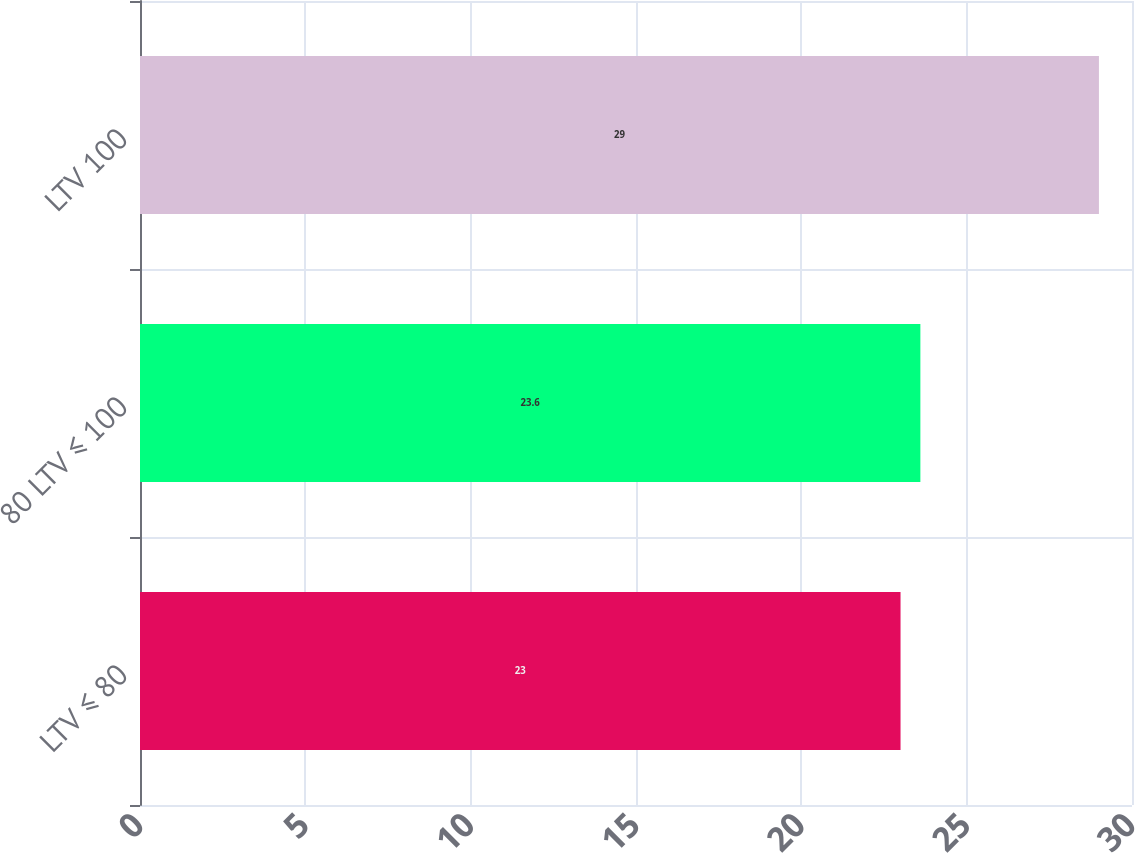<chart> <loc_0><loc_0><loc_500><loc_500><bar_chart><fcel>LTV ≤ 80<fcel>80 LTV ≤ 100<fcel>LTV 100<nl><fcel>23<fcel>23.6<fcel>29<nl></chart> 